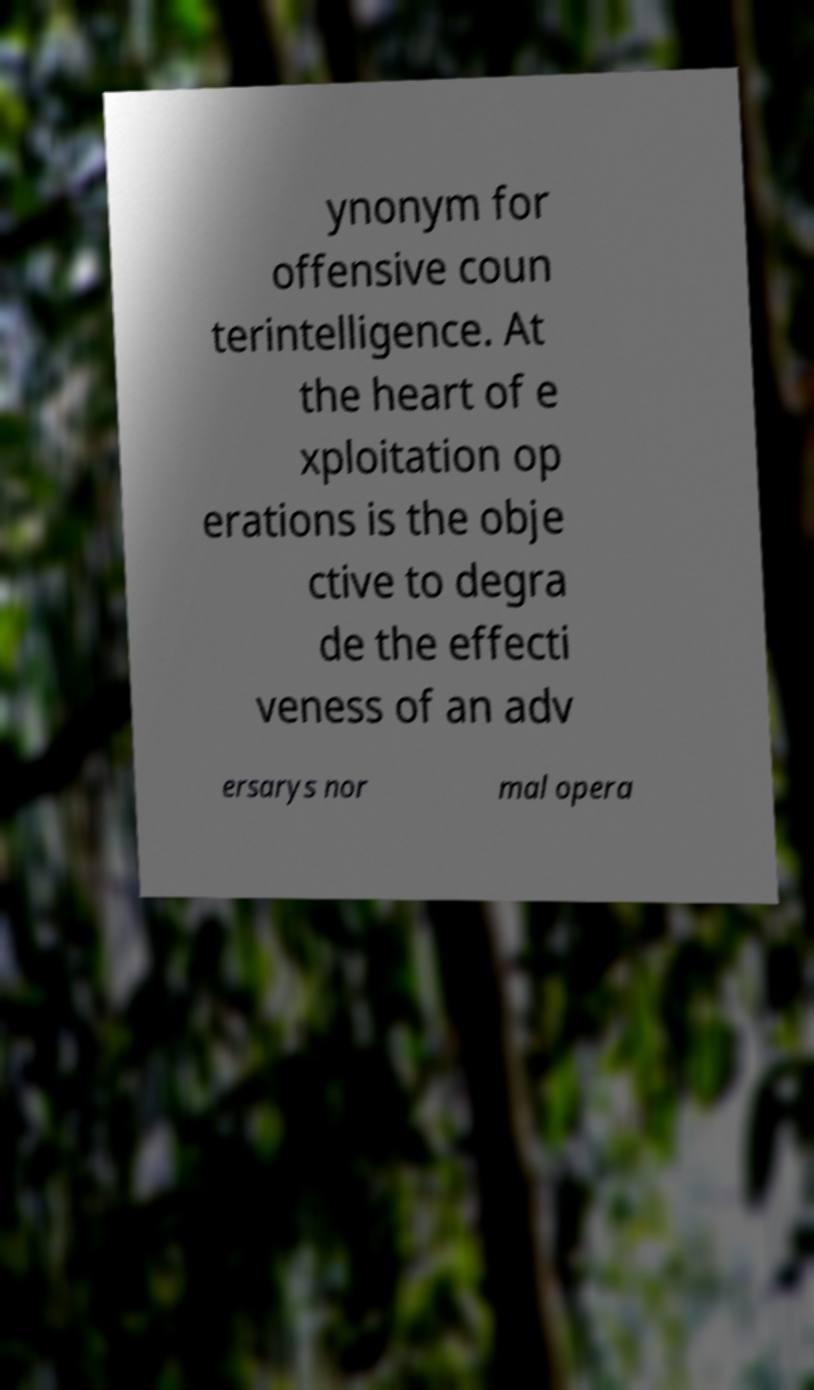What messages or text are displayed in this image? I need them in a readable, typed format. ynonym for offensive coun terintelligence. At the heart of e xploitation op erations is the obje ctive to degra de the effecti veness of an adv ersarys nor mal opera 